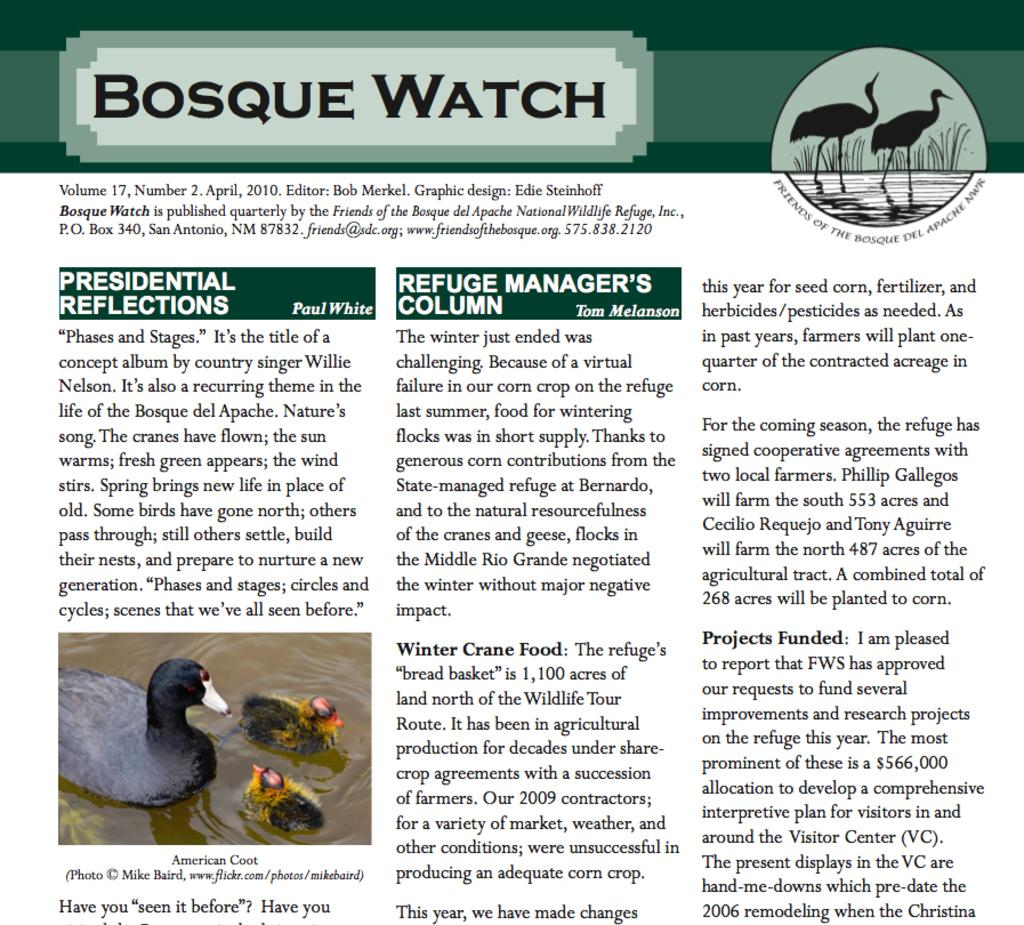What type of visual is the image in the picture? The image is a poster. What can be found on the poster besides the image? There is writing on the poster. What is depicted in the image on the poster? The image contains ducks. Where are the ducks located in the image? The ducks are in the water. What direction is the doctor facing in the image? There is no doctor present in the image; it features ducks in the water. Can you tell me how many ducks are slipping on the ice in the image? There is no ice present in the image, and the ducks are in the water, not slipping. 